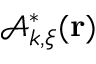<formula> <loc_0><loc_0><loc_500><loc_500>\mathcal { A } _ { { \boldsymbol k } , { \boldsymbol \xi } } ^ { * } ( { r } )</formula> 